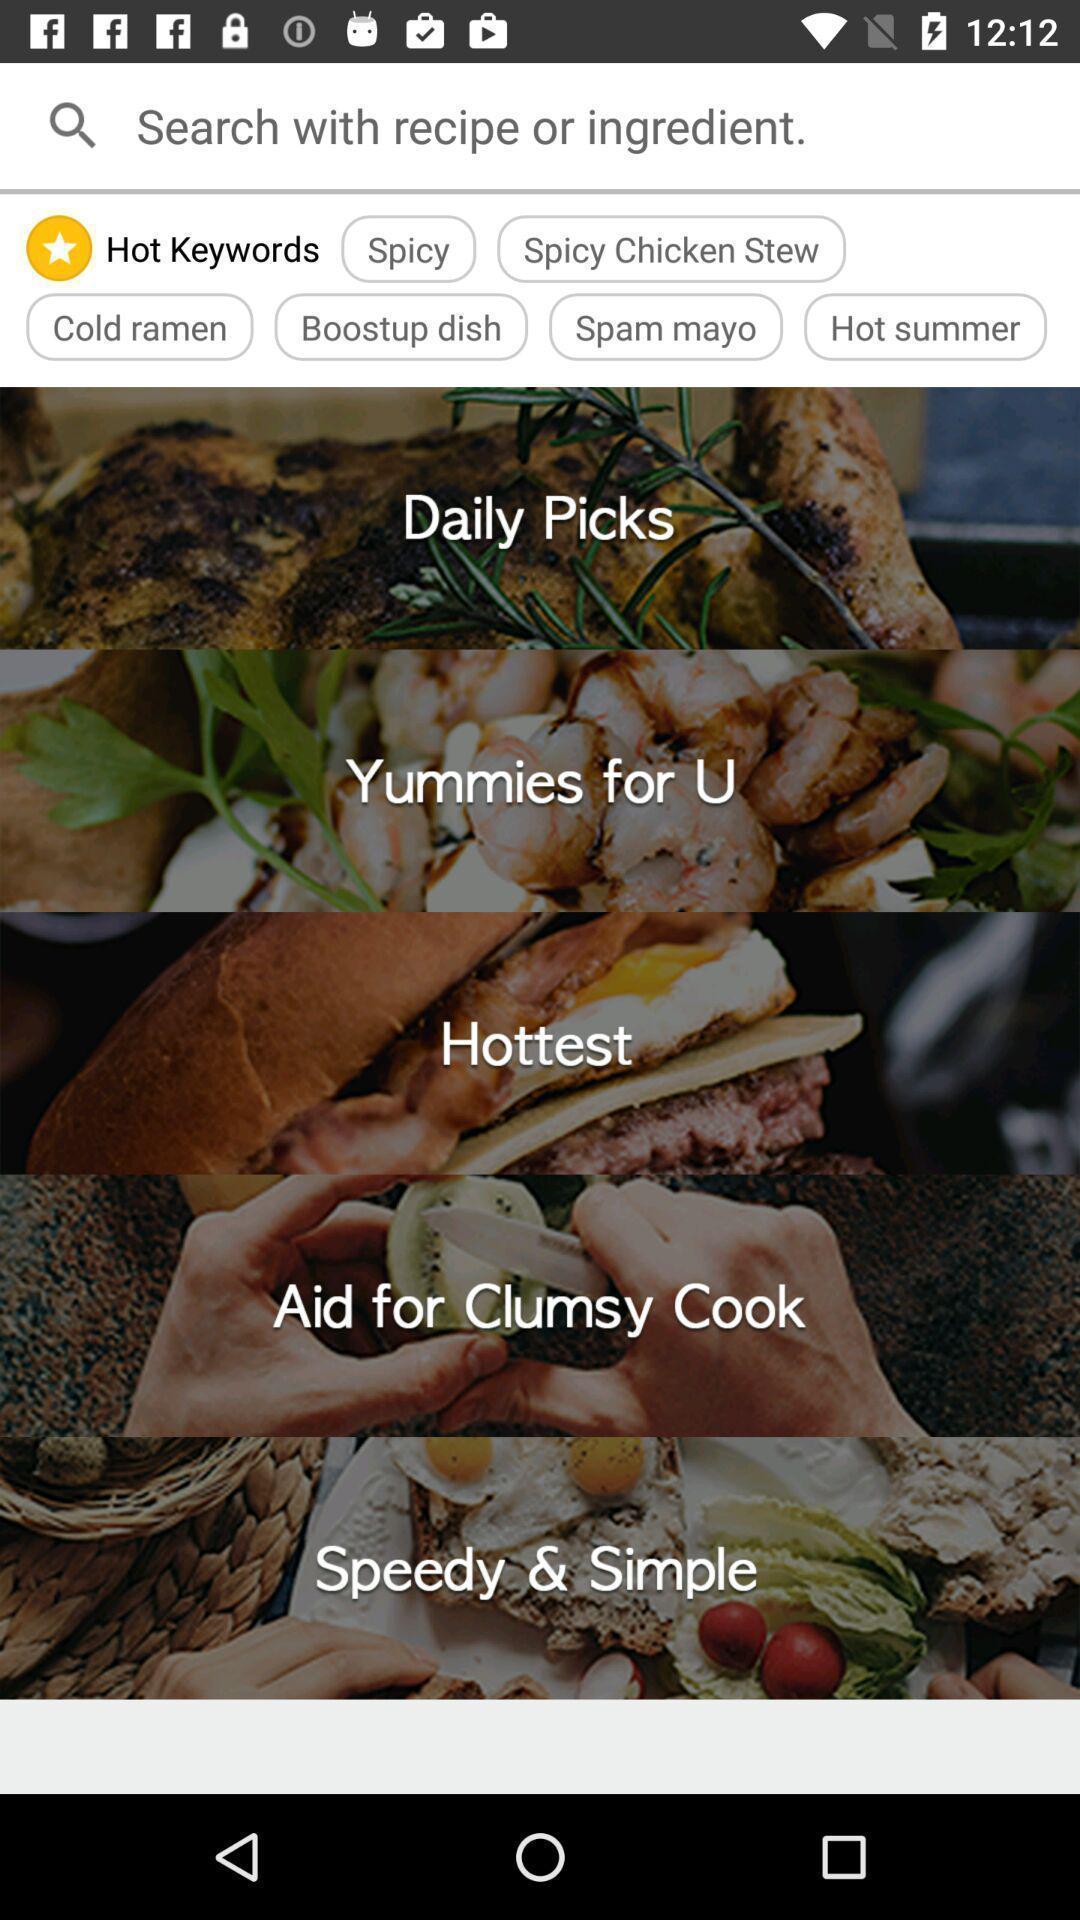Explain the elements present in this screenshot. Search page with various food items in food application. 